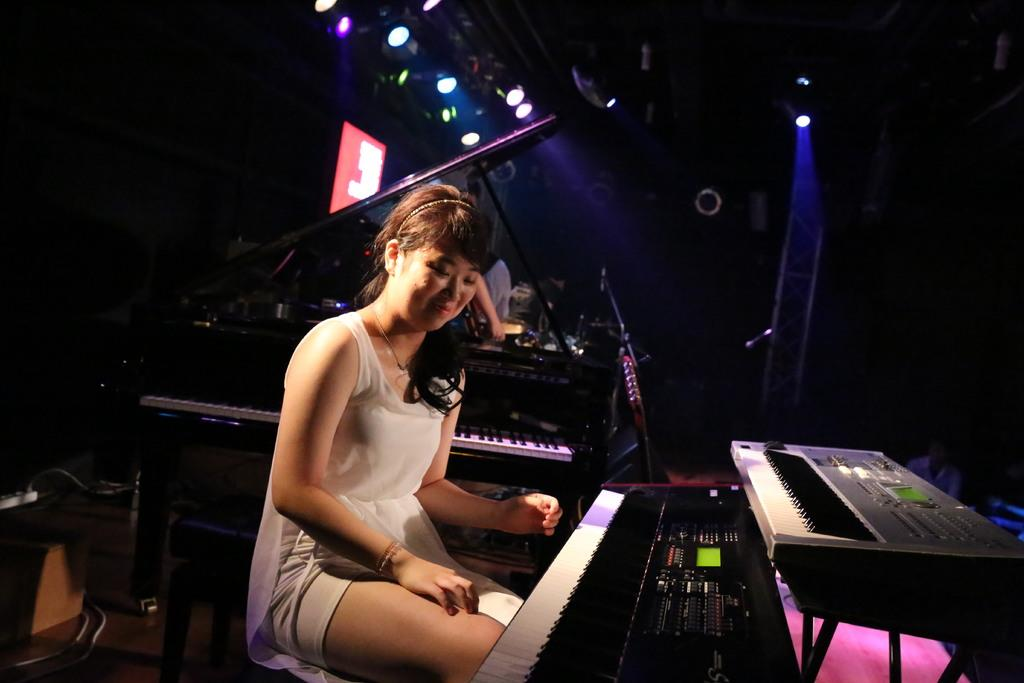Who is present in the image? There is a woman in the image. What is the woman doing in the image? The woman is sitting on a chair in front of a keyboard. Are there any other musical instruments or equipment in the image? Yes, there is another musical keyboard in the background. Can you describe the hand visible in the background? There is a hand of another person visible in the background. What is visible at the top of the image? There are lights visible at the top of the image. Can you tell me how many cacti are visible in the image? There are no cacti present in the image. What type of conversation is the woman having with the person whose hand is visible in the background? The image does not show any conversation or interaction between the woman and the person whose hand is visible in the background. 